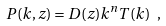<formula> <loc_0><loc_0><loc_500><loc_500>P ( k , z ) = D ( z ) k ^ { n } T ( k ) \ ,</formula> 